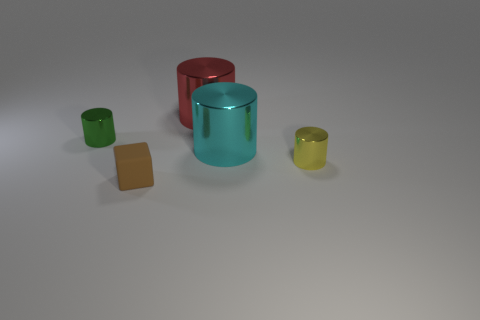What shape is the tiny object that is on the left side of the tiny matte thing?
Your answer should be very brief. Cylinder. The object that is on the right side of the big red metal thing and on the left side of the small yellow shiny object has what shape?
Provide a succinct answer. Cylinder. What number of cyan things are rubber things or big cylinders?
Offer a very short reply. 1. There is a object that is in front of the small yellow cylinder right of the green metal cylinder; what is its size?
Provide a succinct answer. Small. There is a brown object that is the same size as the yellow cylinder; what is it made of?
Ensure brevity in your answer.  Rubber. How many other things are there of the same size as the brown object?
Offer a terse response. 2. How many cylinders are small green objects or red objects?
Give a very brief answer. 2. Is there anything else that has the same material as the block?
Offer a terse response. No. What is the small cylinder to the left of the tiny metal thing in front of the shiny cylinder that is on the left side of the small cube made of?
Offer a terse response. Metal. How many cyan objects have the same material as the green thing?
Offer a very short reply. 1. 